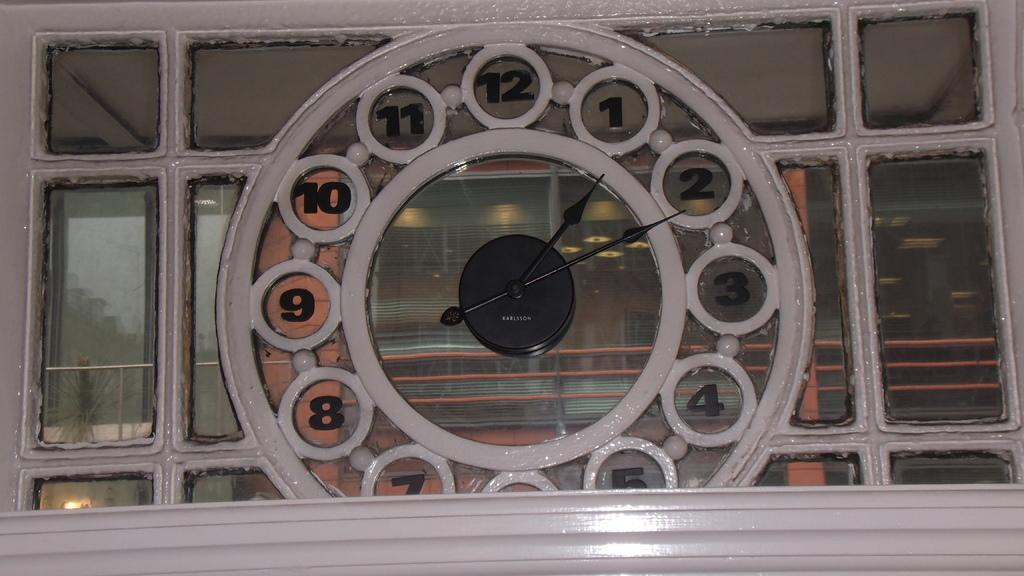What object in the image is used for measuring time? There is a clock in the image that is used for measuring time. What material is present in the image that is transparent or translucent? There is glass in the image that is transparent or translucent. What songs can be heard playing in the background of the image? There is no audio or sound present in the image, so it is not possible to determine what songs might be heard. 